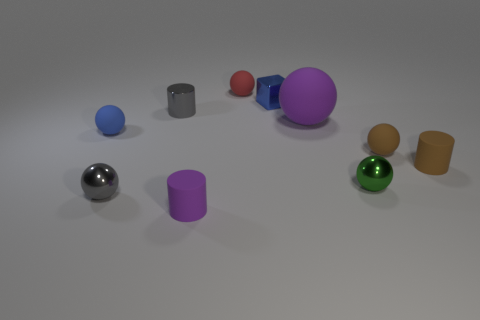There is a metallic sphere that is left of the metallic cylinder; is its size the same as the gray cylinder?
Your answer should be compact. Yes. How many other things are made of the same material as the brown cylinder?
Provide a succinct answer. 5. What number of green objects are tiny cubes or balls?
Make the answer very short. 1. What is the size of the matte sphere that is the same color as the block?
Keep it short and to the point. Small. There is a small blue ball; how many brown cylinders are to the right of it?
Give a very brief answer. 1. There is a matte cylinder that is in front of the tiny brown rubber thing in front of the brown object behind the brown cylinder; how big is it?
Provide a short and direct response. Small. Are there any tiny purple matte cylinders in front of the tiny gray shiny cylinder that is on the right side of the small sphere that is in front of the green thing?
Your answer should be compact. Yes. Is the number of shiny cylinders greater than the number of cyan rubber cylinders?
Give a very brief answer. Yes. What is the color of the matte ball in front of the blue rubber object?
Provide a short and direct response. Brown. Are there more metal cylinders in front of the red rubber ball than big green metal cubes?
Offer a terse response. Yes. 